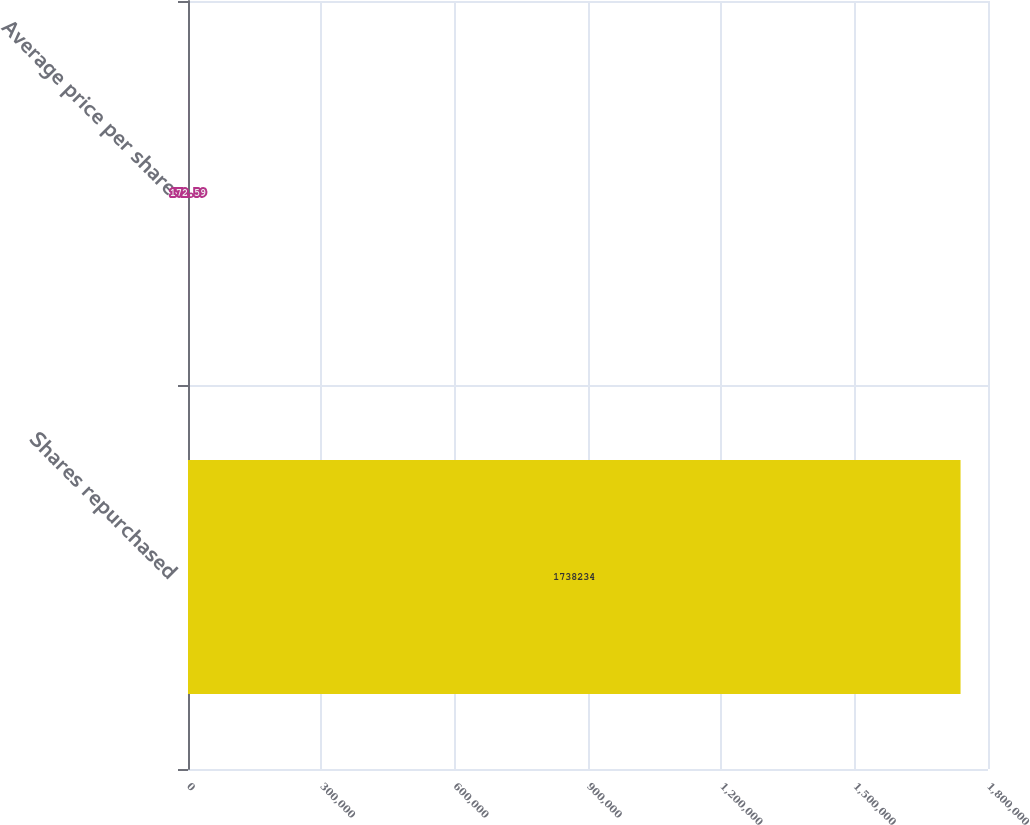Convert chart to OTSL. <chart><loc_0><loc_0><loc_500><loc_500><bar_chart><fcel>Shares repurchased<fcel>Average price per share<nl><fcel>1.73823e+06<fcel>172.59<nl></chart> 